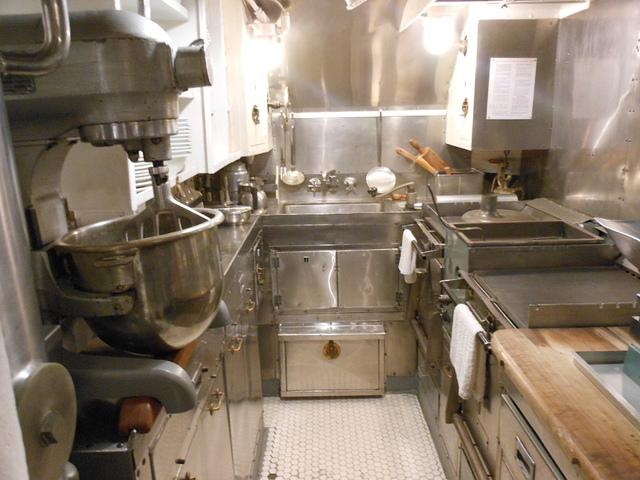How is dough kneaded here? Please explain your reasoning. by machine. There is a large whisking machine to the left. people put stuff in it and turn it on to knead the dough. 